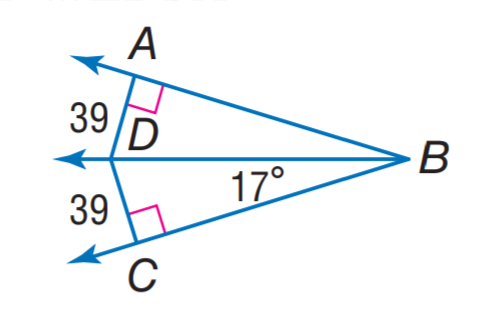Based on the image, directly select the correct answer for the following question:
Question: Find m \angle D B A.
Choices:
A: 17
B: 22
C: 32
D: 39 Answer:A 